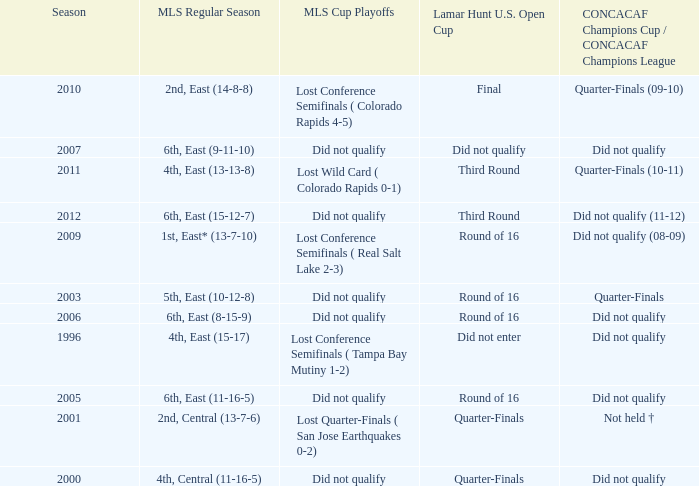What was the lamar hunt u.s. open cup when concacaf champions cup / concacaf champions league was did not qualify and mls regular season was 4th, central (11-16-5)? Quarter-Finals. 